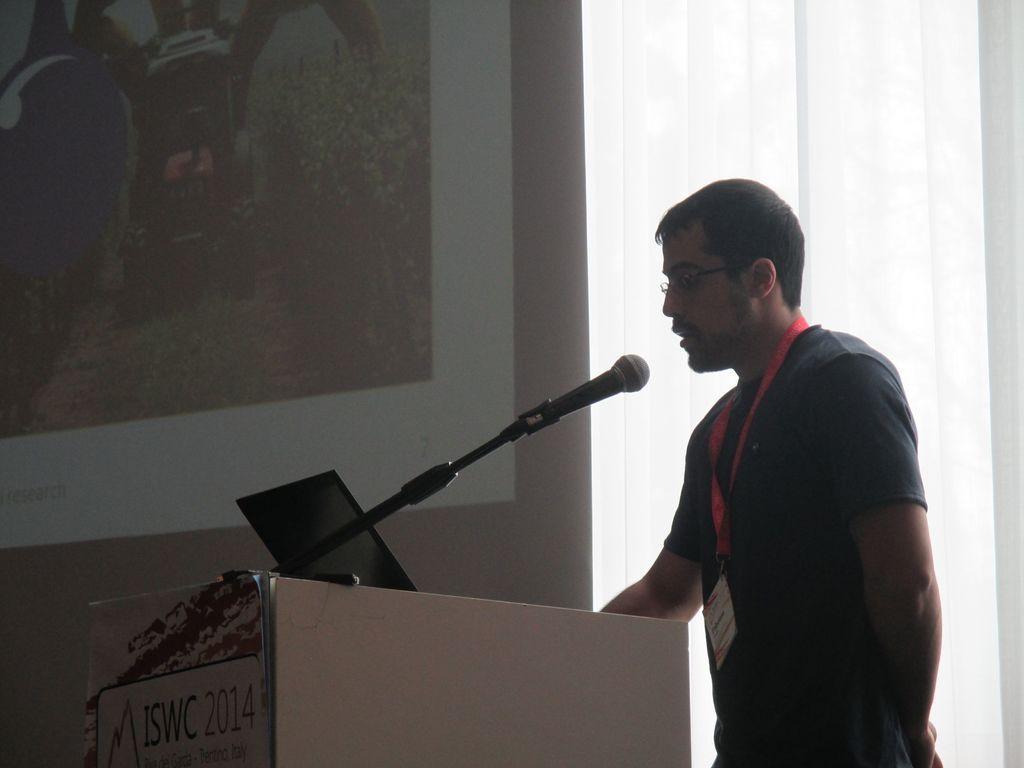In one or two sentences, can you explain what this image depicts? In the center of the image there is a person talking in a mic. There is a podium. In the background of the image there is a wall. 